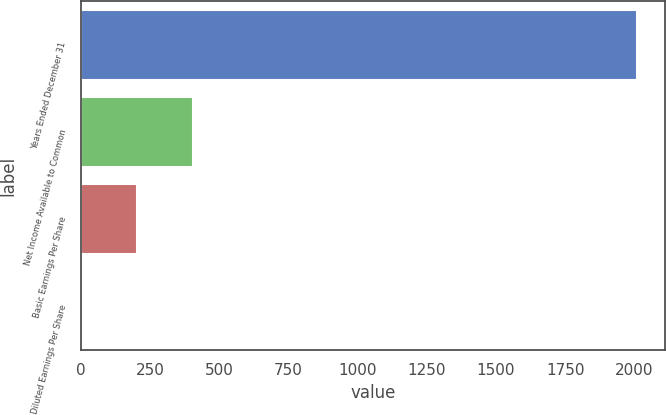Convert chart to OTSL. <chart><loc_0><loc_0><loc_500><loc_500><bar_chart><fcel>Years Ended December 31<fcel>Net Income Available to Common<fcel>Basic Earnings Per Share<fcel>Diluted Earnings Per Share<nl><fcel>2009<fcel>402.53<fcel>201.72<fcel>0.91<nl></chart> 